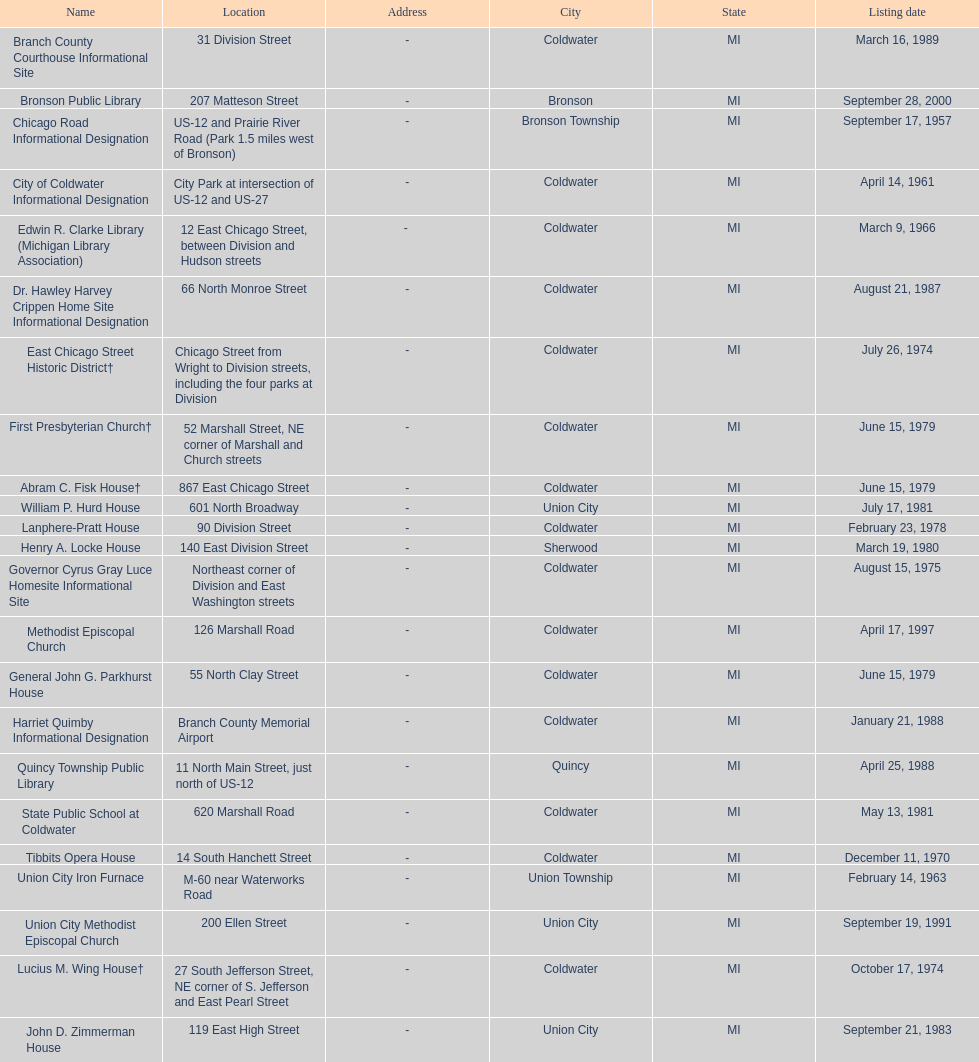What is the name with the only listing date on april 14, 1961 City of Coldwater. 